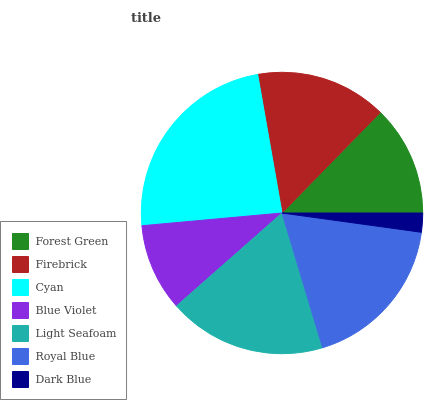Is Dark Blue the minimum?
Answer yes or no. Yes. Is Cyan the maximum?
Answer yes or no. Yes. Is Firebrick the minimum?
Answer yes or no. No. Is Firebrick the maximum?
Answer yes or no. No. Is Firebrick greater than Forest Green?
Answer yes or no. Yes. Is Forest Green less than Firebrick?
Answer yes or no. Yes. Is Forest Green greater than Firebrick?
Answer yes or no. No. Is Firebrick less than Forest Green?
Answer yes or no. No. Is Firebrick the high median?
Answer yes or no. Yes. Is Firebrick the low median?
Answer yes or no. Yes. Is Forest Green the high median?
Answer yes or no. No. Is Blue Violet the low median?
Answer yes or no. No. 